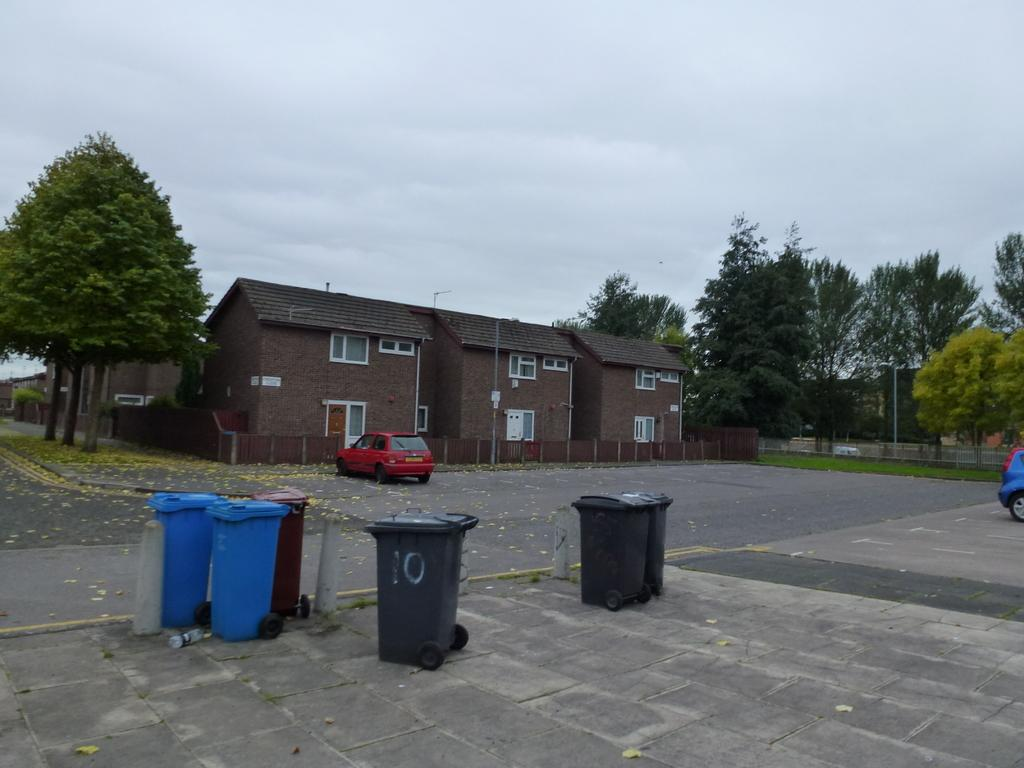<image>
Offer a succinct explanation of the picture presented. Some trash cans are sitting outside an apartment building, the closest of which has the number 10 painted on it. 